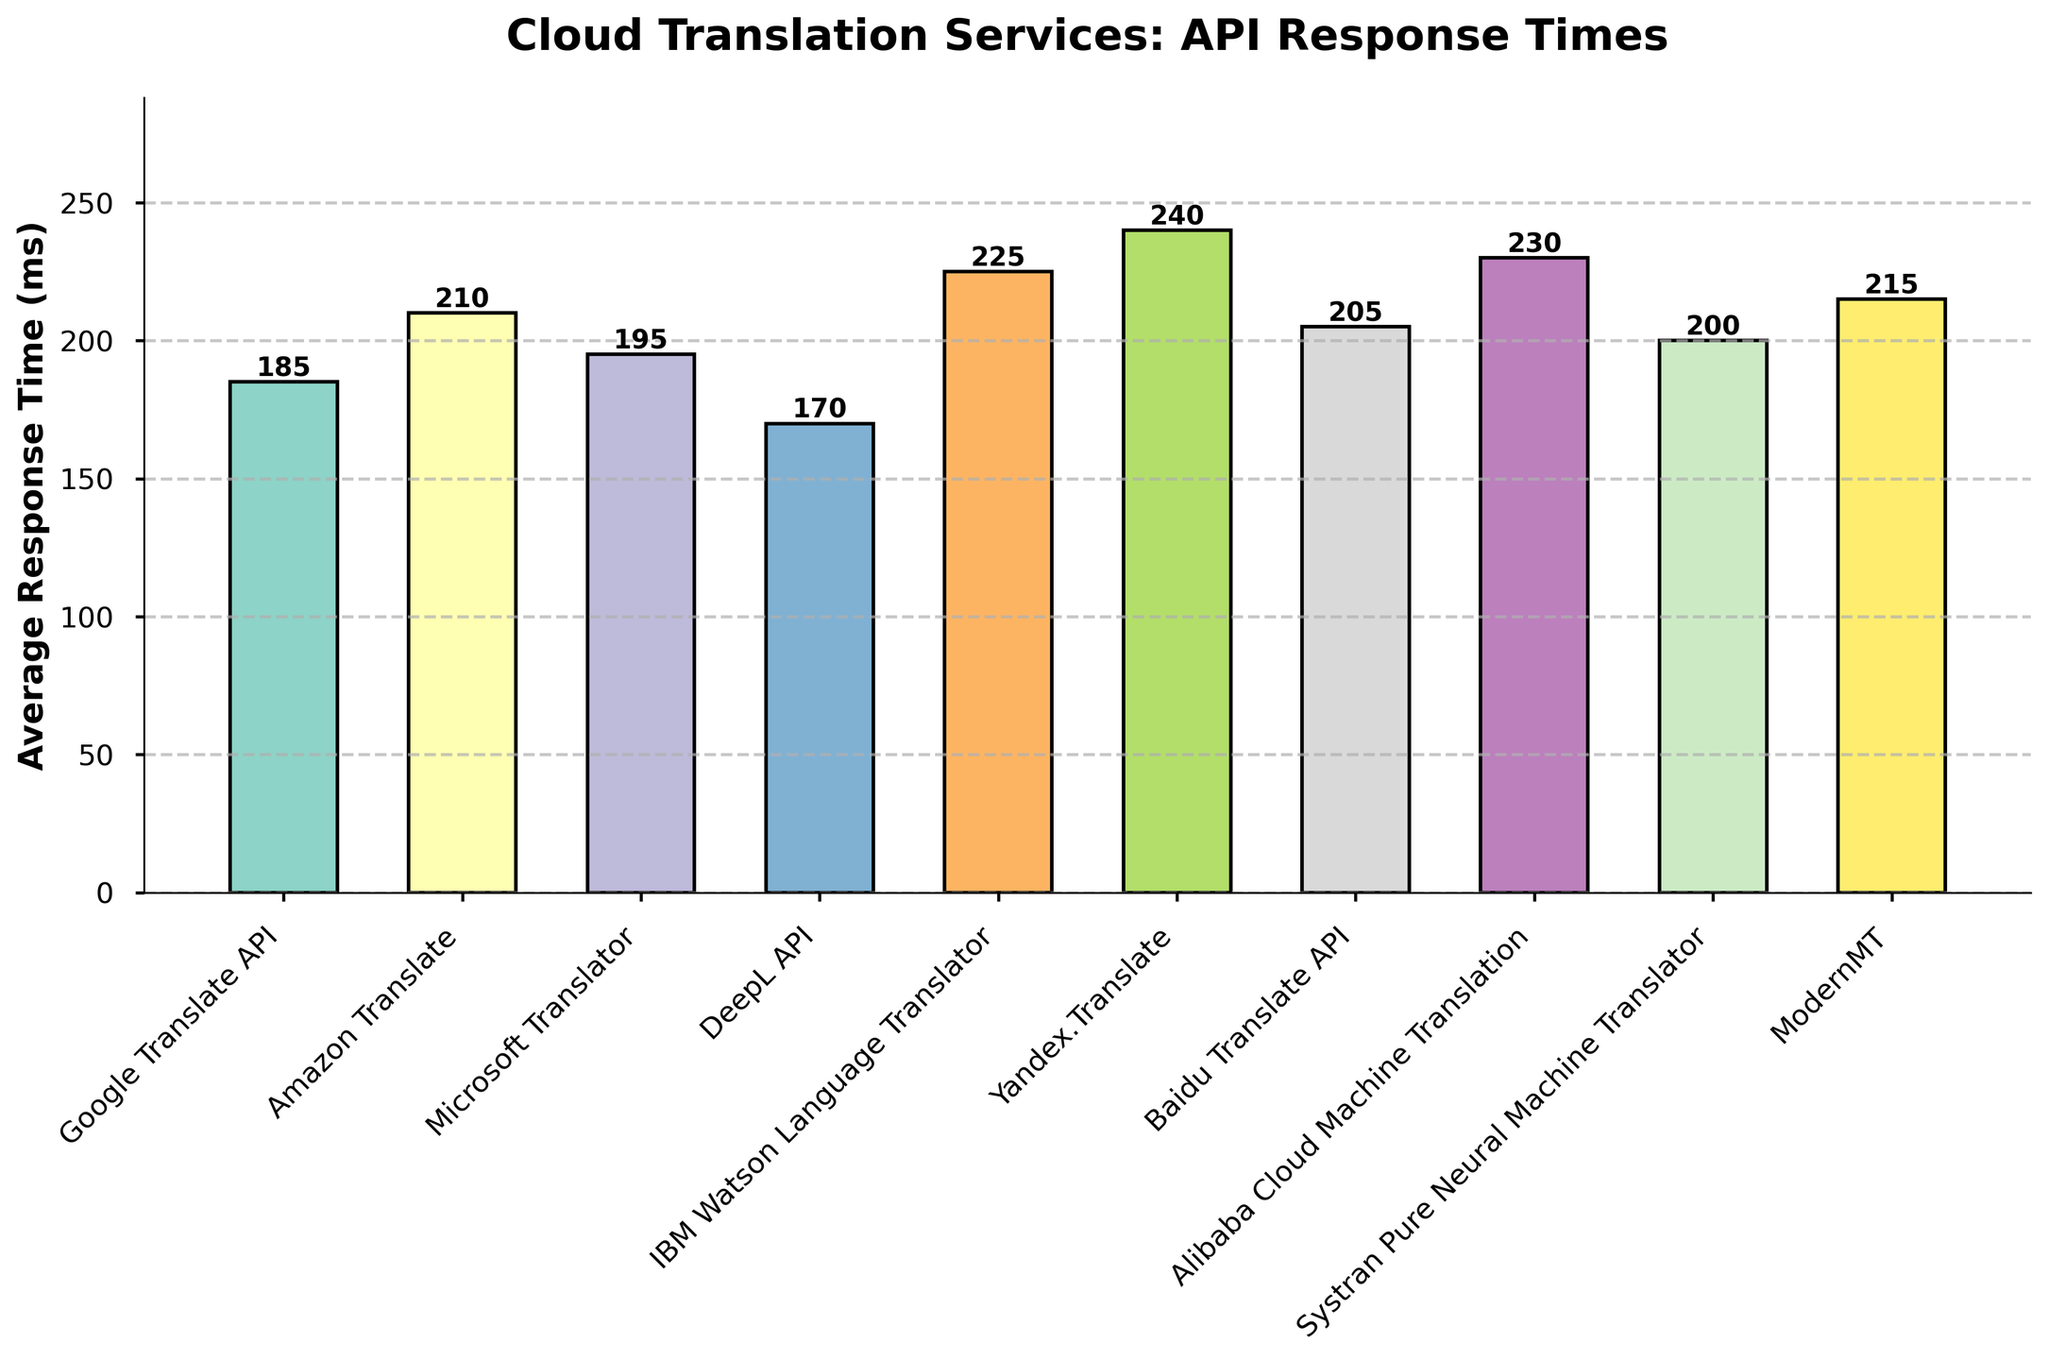What is the cloud translation service with the highest average response time? First, identify the service with the tallest bar in the chart. The tallest bar represents the highest value. Yandex.Translate has the highest average response time as its bar is the tallest.
Answer: Yandex.Translate Which service has a lower average response time, Google Translate API or Amazon Translate? Compare the heights of the bars for Google Translate API and Amazon Translate. Google Translate API's bar is shorter, indicating a lower average response time.
Answer: Google Translate API What is the difference in average response time between IBM Watson Language Translator and DeepL API? Observe the bars for IBM Watson Language Translator and DeepL API and note their heights. Subtract DeepL API's response time (170 ms) from IBM Watson's (225 ms) to find the difference: 225 - 170 = 55 ms.
Answer: 55 ms Which services have an average response time greater than 200 ms? Identify all bars that exceed the 200 ms mark on the y-axis. These include Amazon Translate, IBM Watson Language Translator, Yandex.Translate, Alibaba Cloud Machine Translation, Systran Pure Neural Machine Translator, and ModernMT.
Answer: Amazon Translate, IBM Watson Language Translator, Yandex.Translate, Alibaba Cloud Machine Translation, Systran Pure Neural Machine Translator, ModernMT What is the average response time of the three fastest services? First, identify the three services with the shortest bars: DeepL API (170 ms), Google Translate API (185 ms), and Microsoft Translator (195 ms). Calculate their average: (170 + 185 + 195) / 3 = 550 / 3 ≈ 183.33 ms.
Answer: 183.33 ms How does Microsoft Translator's average response time compare to Baidu Translate API? Compare the heights of the bars for Microsoft Translator (195 ms) and Baidu Translate API (205 ms). Microsoft Translator's bar is shorter, indicating a lower average response time.
Answer: Microsoft Translator is faster Which service has the median average response time and what is it? List all the services' average response times in ascending order: 170, 185, 195, 200, 205, 210, 215, 225, 230, 240. The median is the middle value, so for 10 services, it's the average of the 5th and 6th values: (205 + 210) / 2 = 207.5 ms.
Answer: 207.5 ms Is there a significant difference in response times between the highest and the lowest service? Identify the highest average response time (Yandex.Translate at 240 ms) and the lowest (DeepL API at 170 ms). Calculate the difference: 240 - 170 = 70 ms. This difference is significant.
Answer: 70 ms Which services have average response times within 10 ms of Amazon Translate? Amazon Translate has an average response time of 210 ms. Services within 10 ms can range from 200 to 220 ms. These include Microsoft Translator (195 ms, slightly outside), Baidu Translate API (205 ms), and ModernMT (215 ms).
Answer: Baidu Translate API and ModernMT 